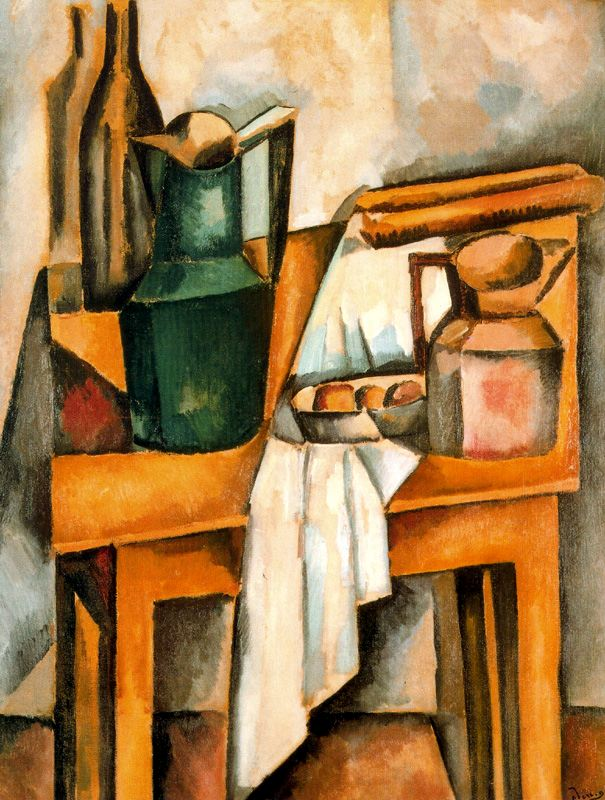Can you explain the significance of the contrasting colors used in the painting? In this Cubist painting, the artist utilizes contrasting colors to underscore different elements, aiding in the viewer's navigation through the abstracted space. The green vase and blue book stand out against the more subdued background, drawing attention to these objects and suggesting their importance in the composition. This use of color helps to separate elements within the fragmented Cubist style, making each object distinct while maintaining overall harmony. 